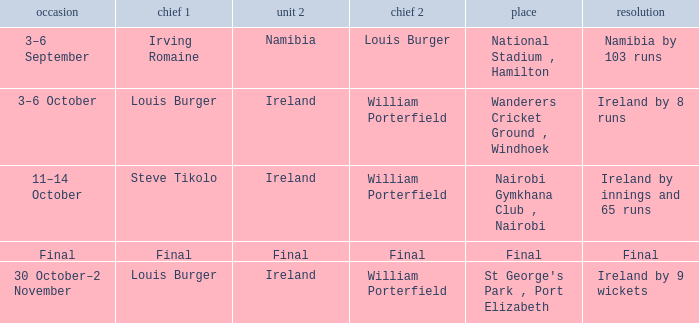Which Result has a Captain 1 of louis burger, and a Date of 30 october–2 november? Ireland by 9 wickets. 